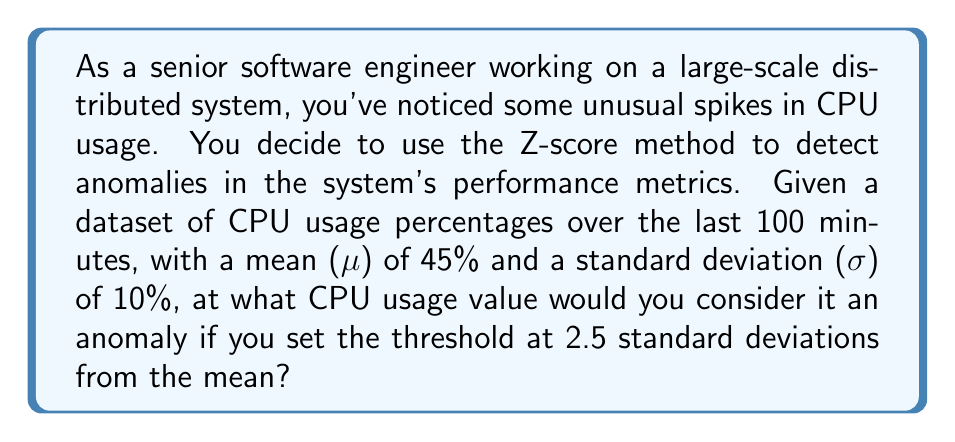What is the answer to this math problem? To solve this problem, we'll use the Z-score method for anomaly detection. The Z-score represents the number of standard deviations a data point is from the mean. The formula for Z-score is:

$$Z = \frac{X - \mu}{\sigma}$$

Where:
$X$ is the value we're solving for (the anomaly threshold)
$\mu$ is the mean (45%)
$\sigma$ is the standard deviation (10%)

We want to find the value of $X$ that corresponds to a Z-score of 2.5, as this is our chosen threshold for anomalies. So, we'll use:

$$2.5 = \frac{X - 45}{10}$$

Now, let's solve for $X$:

1. Multiply both sides by 10:
   $$25 = X - 45$$

2. Add 45 to both sides:
   $$70 = X$$

Therefore, any CPU usage value at or above 70% would be considered an anomaly.

To double-check, we can calculate the Z-score for 70%:

$$Z = \frac{70 - 45}{10} = 2.5$$

This confirms our calculation is correct.
Answer: 70% 